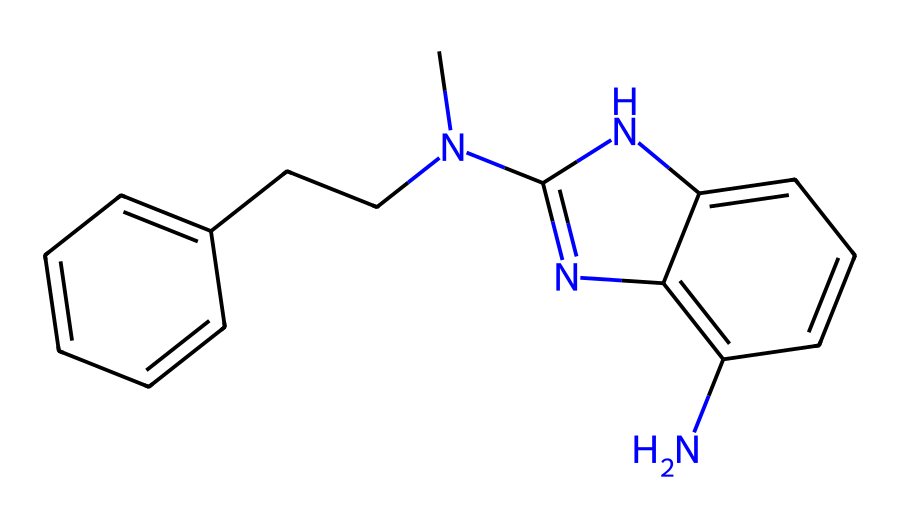how many nitrogen atoms are present in this chemical? The SMILES representation includes the letters "N" which denote nitrogen atoms. By counting the occurrences of "N" in the SMILES, we see there are 3 nitrogen atoms present.
Answer: 3 what is the molecular structure classification of this chemical? This chemical contains multiple rings and nitrogen atoms, suggesting it belongs to the class of heterocycles. The presence of both carbon and nitrogen in a cyclic structure classifies it as a heterocyclic compound.
Answer: heterocyclic how many rings are in the chemical structure? By analyzing the SMILES, we identify two instances where the ring closure is indicated by numbers (e.g., C1 and C2). This shows the presence of 2 intertwined cycles.
Answer: 2 does this chemical contain any double bonds? In the provided SMILES, the "=" symbol signifies double bonds between carbon atoms. Observing the structure, there are 2 specified double bonds present in between certain carbon atoms.
Answer: yes what type of drug is indicated by its chemical structure? The structure features a complex arrangement of cyclic systems and nitrogen atoms, characteristic of many pharmacologically active compounds, particularly alkaloids. Therefore, it is most likely an alkaloid drug.
Answer: alkaloid which functional group is primarily represented in this chemical? Looking at the structure, the presence of nitrogen atoms in the context of carbon rings indicates that the primary functional group to consider is amine, since nitrogen can form an amine in this structural context.
Answer: amine what is the total number of carbon atoms in this chemical? The carbon atoms are represented by the letter "C" in the SMILES; counting the occurrences yields a total of 14 carbon atoms present throughout the structure.
Answer: 14 